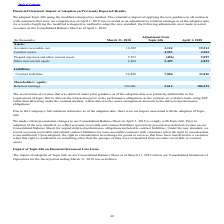According to Agilysys's financial document, What is the tax impact associated with the adoption of Topic 606? Due to the Company's full valuation allowance as of the adoption date, there is no tax impact associated with the adoption of Topic 606.. The document states: "Due to the Company's full valuation allowance as of the adoption date, there is no tax impact associated with the adoption of Topic 606...." Also, What was the adjustment amount to accounts receivable, net? According to the financial document, 3,124 (in thousands). The relevant text states: "Accounts receivable, net 16,389 3,124 19,513..." Also, What was the adjustment amount to contract assets? According to the financial document, 4,583 (in thousands). The relevant text states: "Contract assets — 4,583 4,583..." Also, can you calculate: What was the percentage change in  Accounts receivable, net after  Adjustment from Topic 606? Based on the calculation: 3,124/16,389 , the result is 19.06 (percentage). This is based on the information: "Accounts receivable, net 16,389 3,124 19,513 Accounts receivable, net 16,389 3,124 19,513..." The key data points involved are: 16,389, 3,124. Also, can you calculate: What was the percentage change in  Contract liabilities after  Adjustment from Topic 606? Based on the calculation: 7,006/26,820, the result is 26.12 (percentage). This is based on the information: "Contract liabilities 26,820 7,006 33,826 Contract liabilities 26,820 7,006 33,826..." The key data points involved are: 26,820, 7,006. Also, can you calculate: What was the percentage change in  Retained earnings after  Adjustment from Topic 606? Based on the calculation: 2,614/103,601 , the result is 2.52 (percentage). This is based on the information: "Retained earnings 103,601 2,614 106,215 Retained earnings 103,601 2,614 106,215..." The key data points involved are: 103,601, 2,614. 